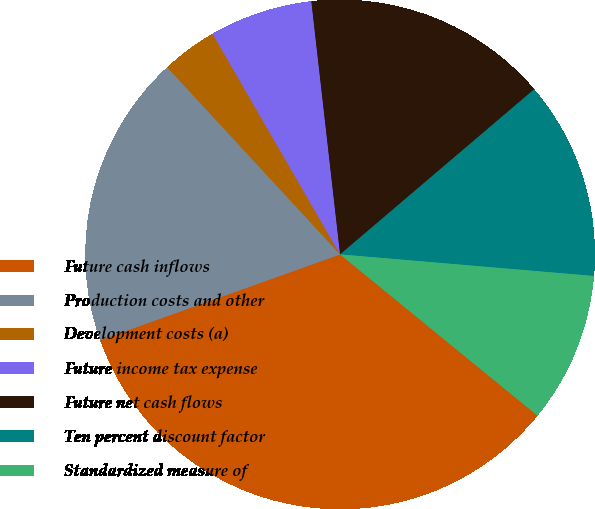Convert chart. <chart><loc_0><loc_0><loc_500><loc_500><pie_chart><fcel>Future cash inflows<fcel>Production costs and other<fcel>Development costs (a)<fcel>Future income tax expense<fcel>Future net cash flows<fcel>Ten percent discount factor<fcel>Standardized measure of<nl><fcel>33.64%<fcel>18.59%<fcel>3.53%<fcel>6.54%<fcel>15.58%<fcel>12.57%<fcel>9.55%<nl></chart> 